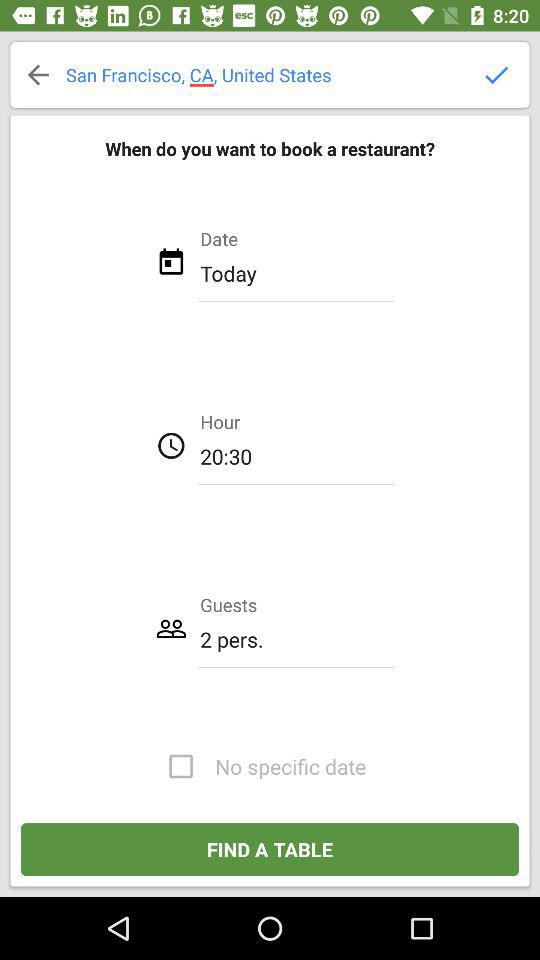Which country is selected? The selected country is the United States. 